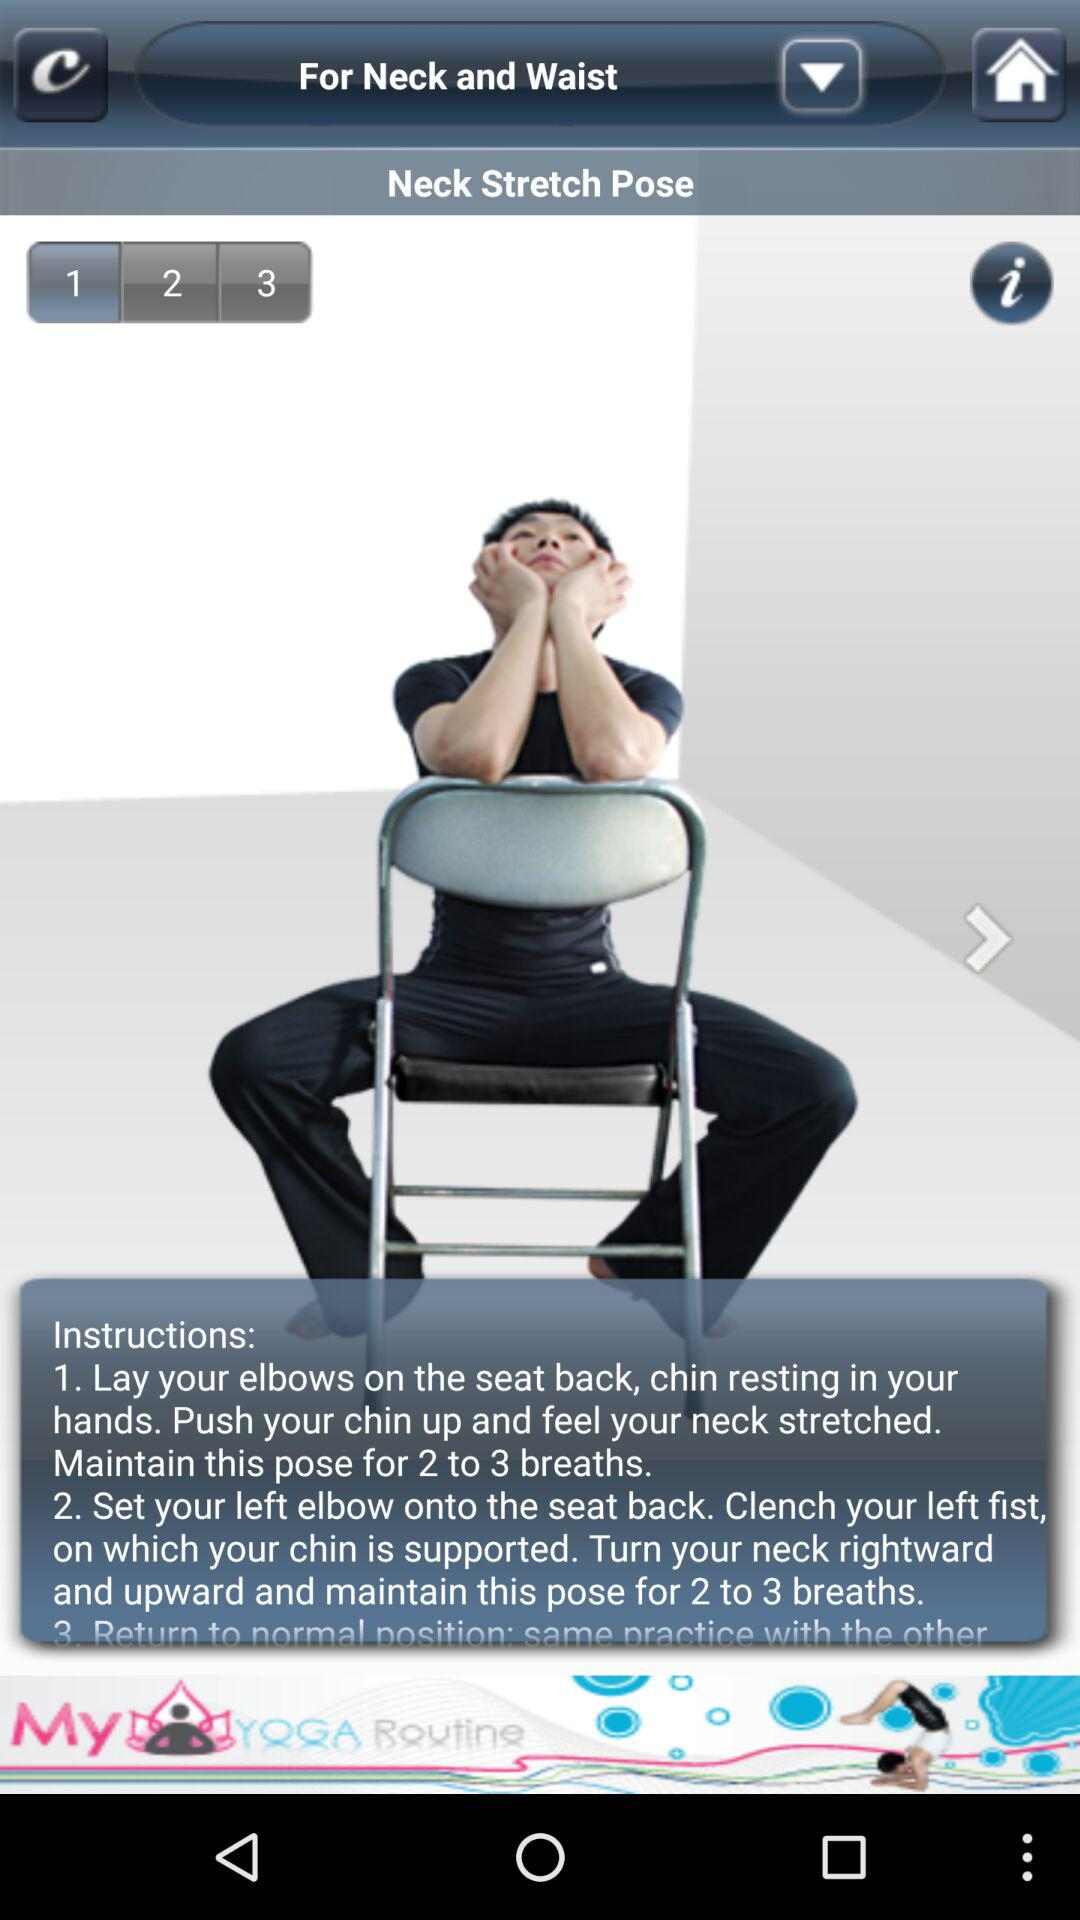What is the pose name? The pose name is Next Stretch Pose. 